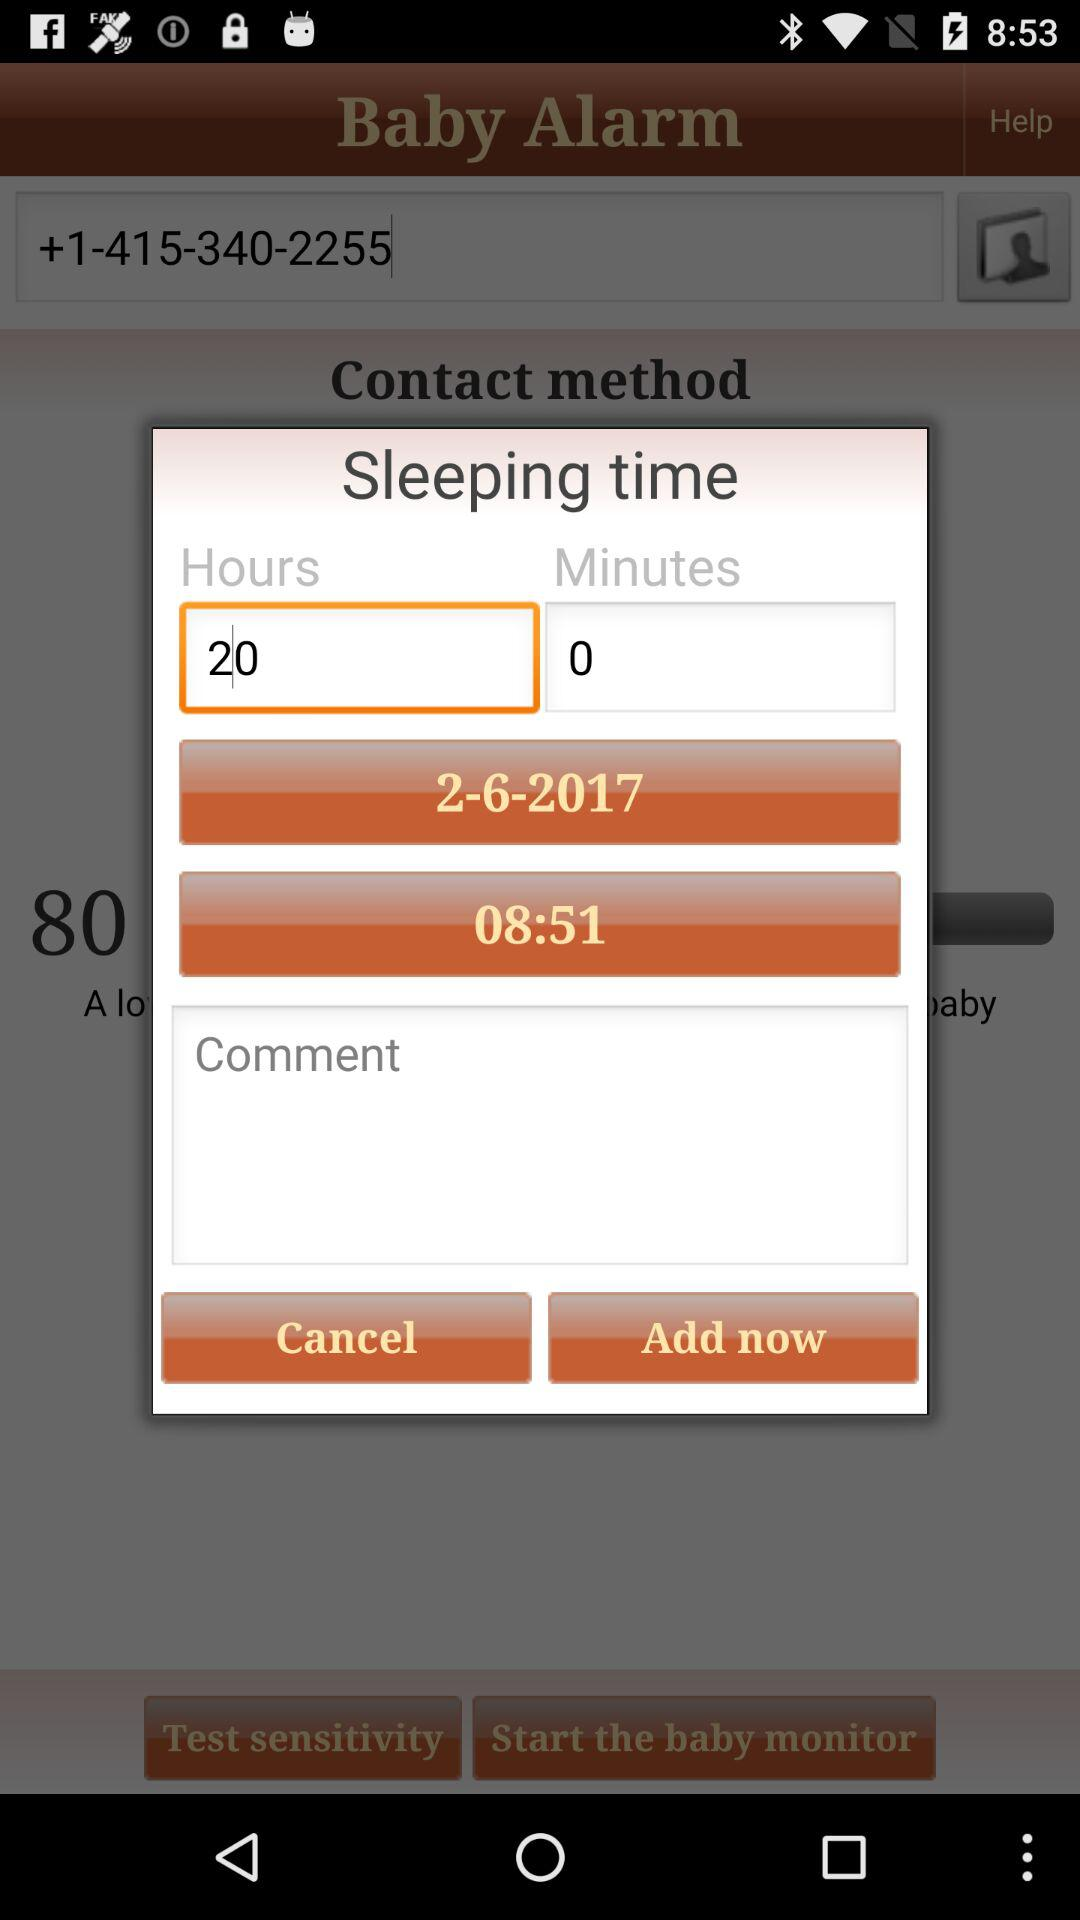How many hours are being slept?
Answer the question using a single word or phrase. 20 